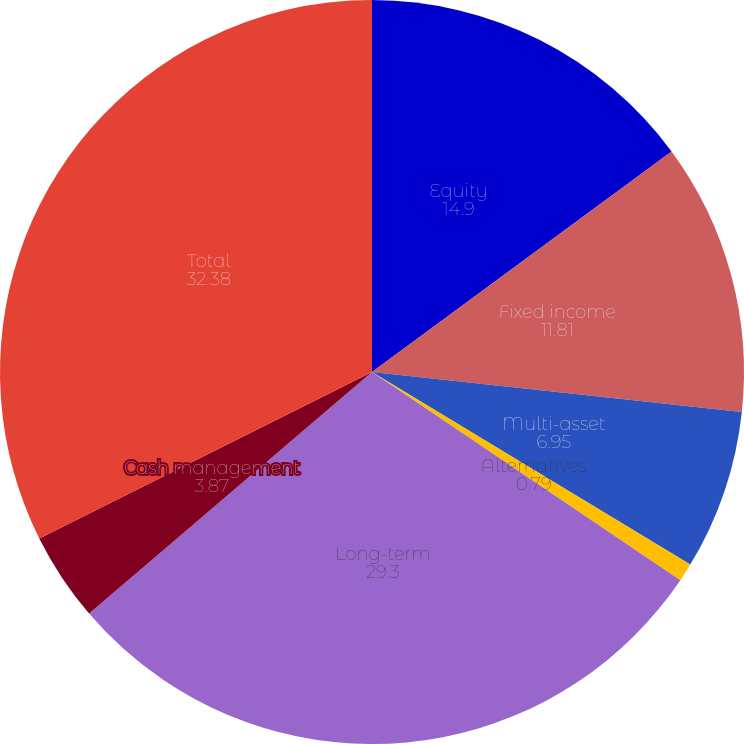<chart> <loc_0><loc_0><loc_500><loc_500><pie_chart><fcel>Equity<fcel>Fixed income<fcel>Multi-asset<fcel>Alternatives<fcel>Long-term<fcel>Cash management<fcel>Total<nl><fcel>14.9%<fcel>11.81%<fcel>6.95%<fcel>0.79%<fcel>29.3%<fcel>3.87%<fcel>32.38%<nl></chart> 